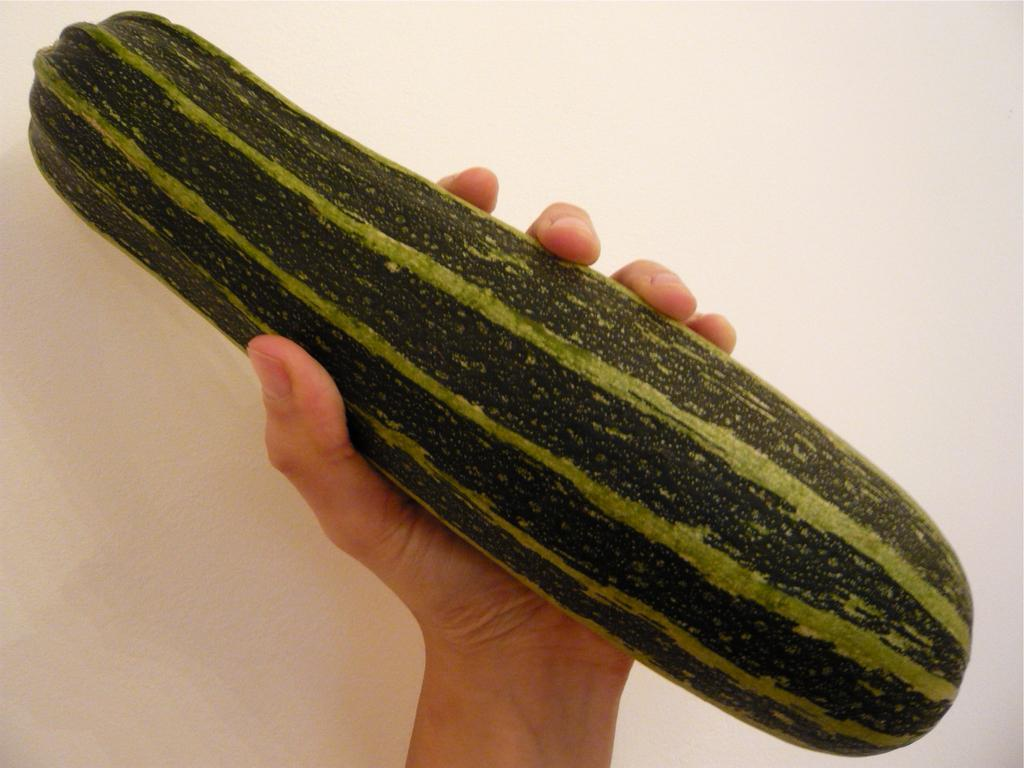What is the person holding in their hand in the image? There is a vegetable in the person's hand in the image. What can be observed about the background of the image? The background of the image is white-colored. What hobbies does the person's mom have, as seen in the image? There is no information about the person's mom or their hobbies in the image. What type of chin does the person have, as seen in the image? There is no information about the person's chin in the image. 